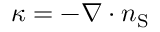Convert formula to latex. <formula><loc_0><loc_0><loc_500><loc_500>\kappa = - \nabla \cdot n _ { S }</formula> 